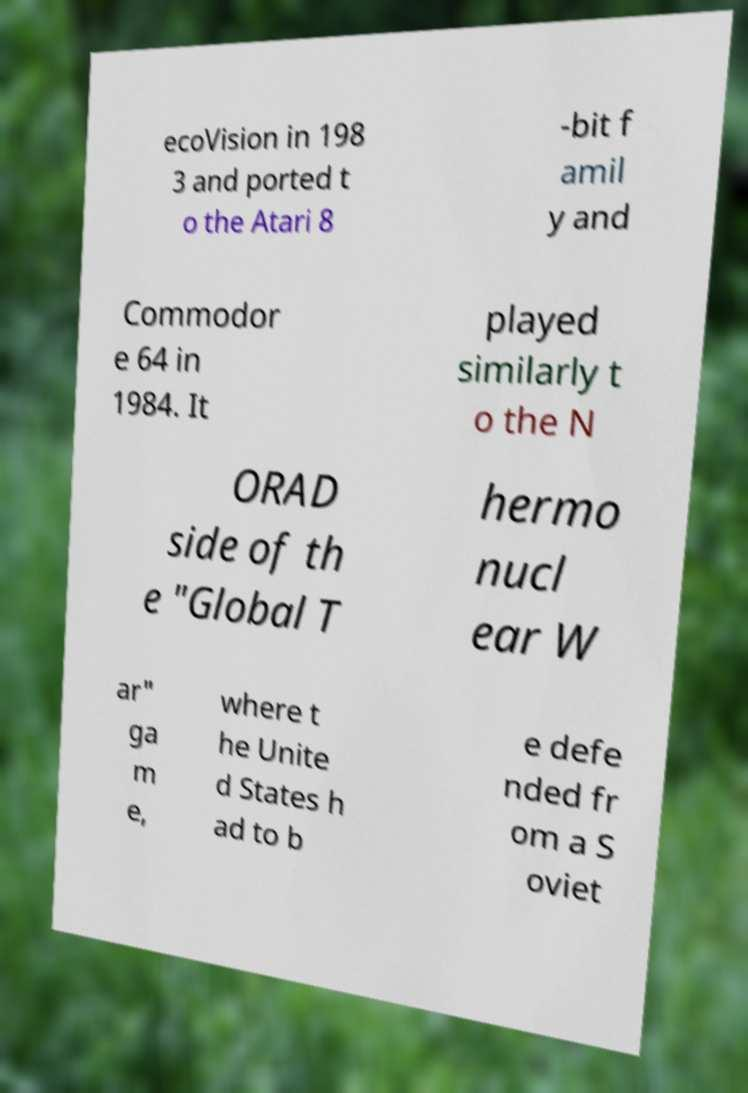For documentation purposes, I need the text within this image transcribed. Could you provide that? ecoVision in 198 3 and ported t o the Atari 8 -bit f amil y and Commodor e 64 in 1984. It played similarly t o the N ORAD side of th e "Global T hermo nucl ear W ar" ga m e, where t he Unite d States h ad to b e defe nded fr om a S oviet 